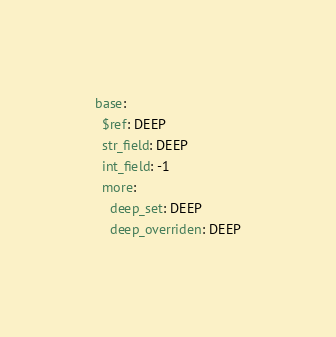<code> <loc_0><loc_0><loc_500><loc_500><_YAML_>base:
  $ref: DEEP
  str_field: DEEP
  int_field: -1
  more:
    deep_set: DEEP
    deep_overriden: DEEP
</code> 